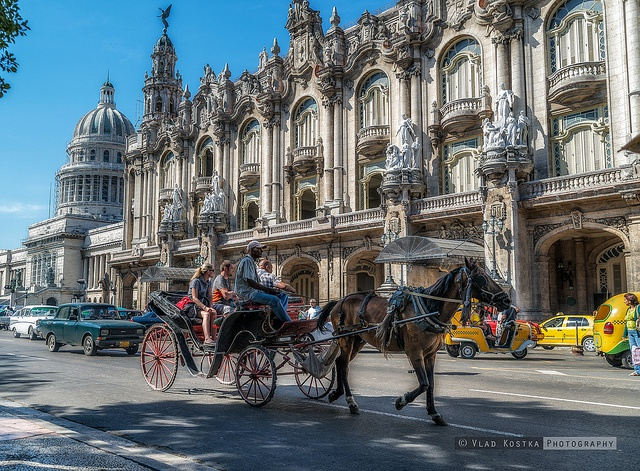Describe the objects in this image and their specific colors. I can see horse in darkgreen, black, gray, and maroon tones, car in darkgreen, black, blue, gray, and darkblue tones, car in darkgreen, black, olive, and gray tones, people in darkgreen, black, gray, navy, and blue tones, and car in darkgreen, gold, black, and olive tones in this image. 